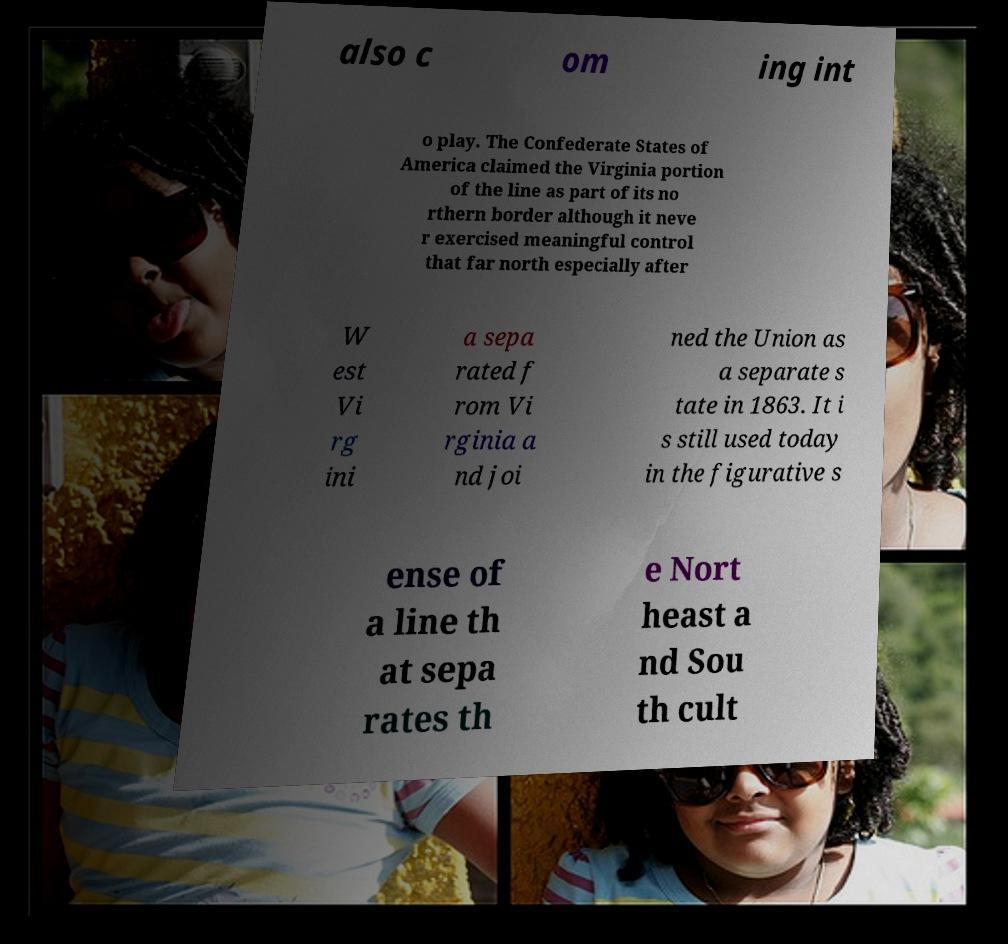Please identify and transcribe the text found in this image. also c om ing int o play. The Confederate States of America claimed the Virginia portion of the line as part of its no rthern border although it neve r exercised meaningful control that far north especially after W est Vi rg ini a sepa rated f rom Vi rginia a nd joi ned the Union as a separate s tate in 1863. It i s still used today in the figurative s ense of a line th at sepa rates th e Nort heast a nd Sou th cult 